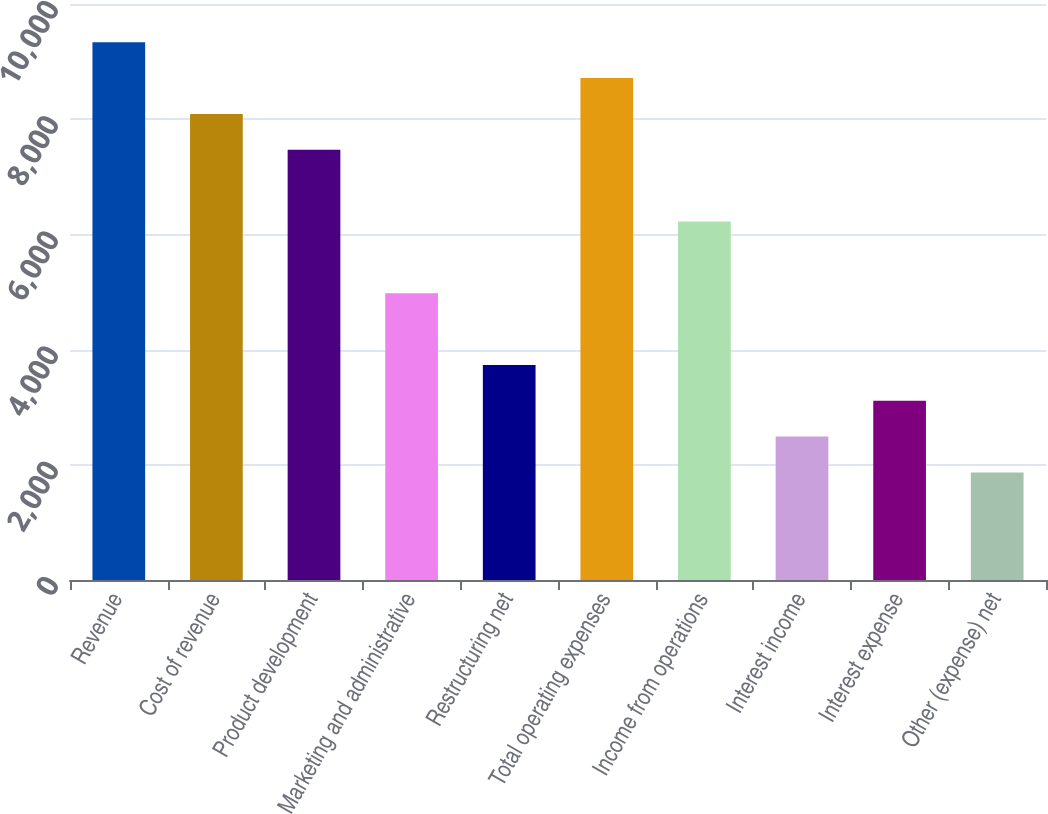<chart> <loc_0><loc_0><loc_500><loc_500><bar_chart><fcel>Revenue<fcel>Cost of revenue<fcel>Product development<fcel>Marketing and administrative<fcel>Restructuring net<fcel>Total operating expenses<fcel>Income from operations<fcel>Interest income<fcel>Interest expense<fcel>Other (expense) net<nl><fcel>9335.9<fcel>8091.14<fcel>7468.76<fcel>4979.24<fcel>3734.48<fcel>8713.52<fcel>6224<fcel>2489.72<fcel>3112.1<fcel>1867.34<nl></chart> 